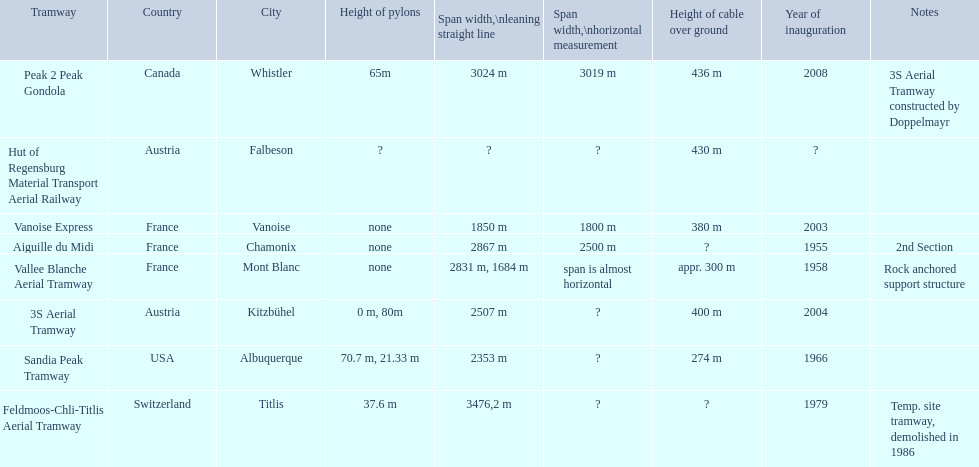When was the aiguille du midi tramway inaugurated? 1955. When was the 3s aerial tramway inaugurated? 2004. Which one was inaugurated first? Aiguille du Midi. 